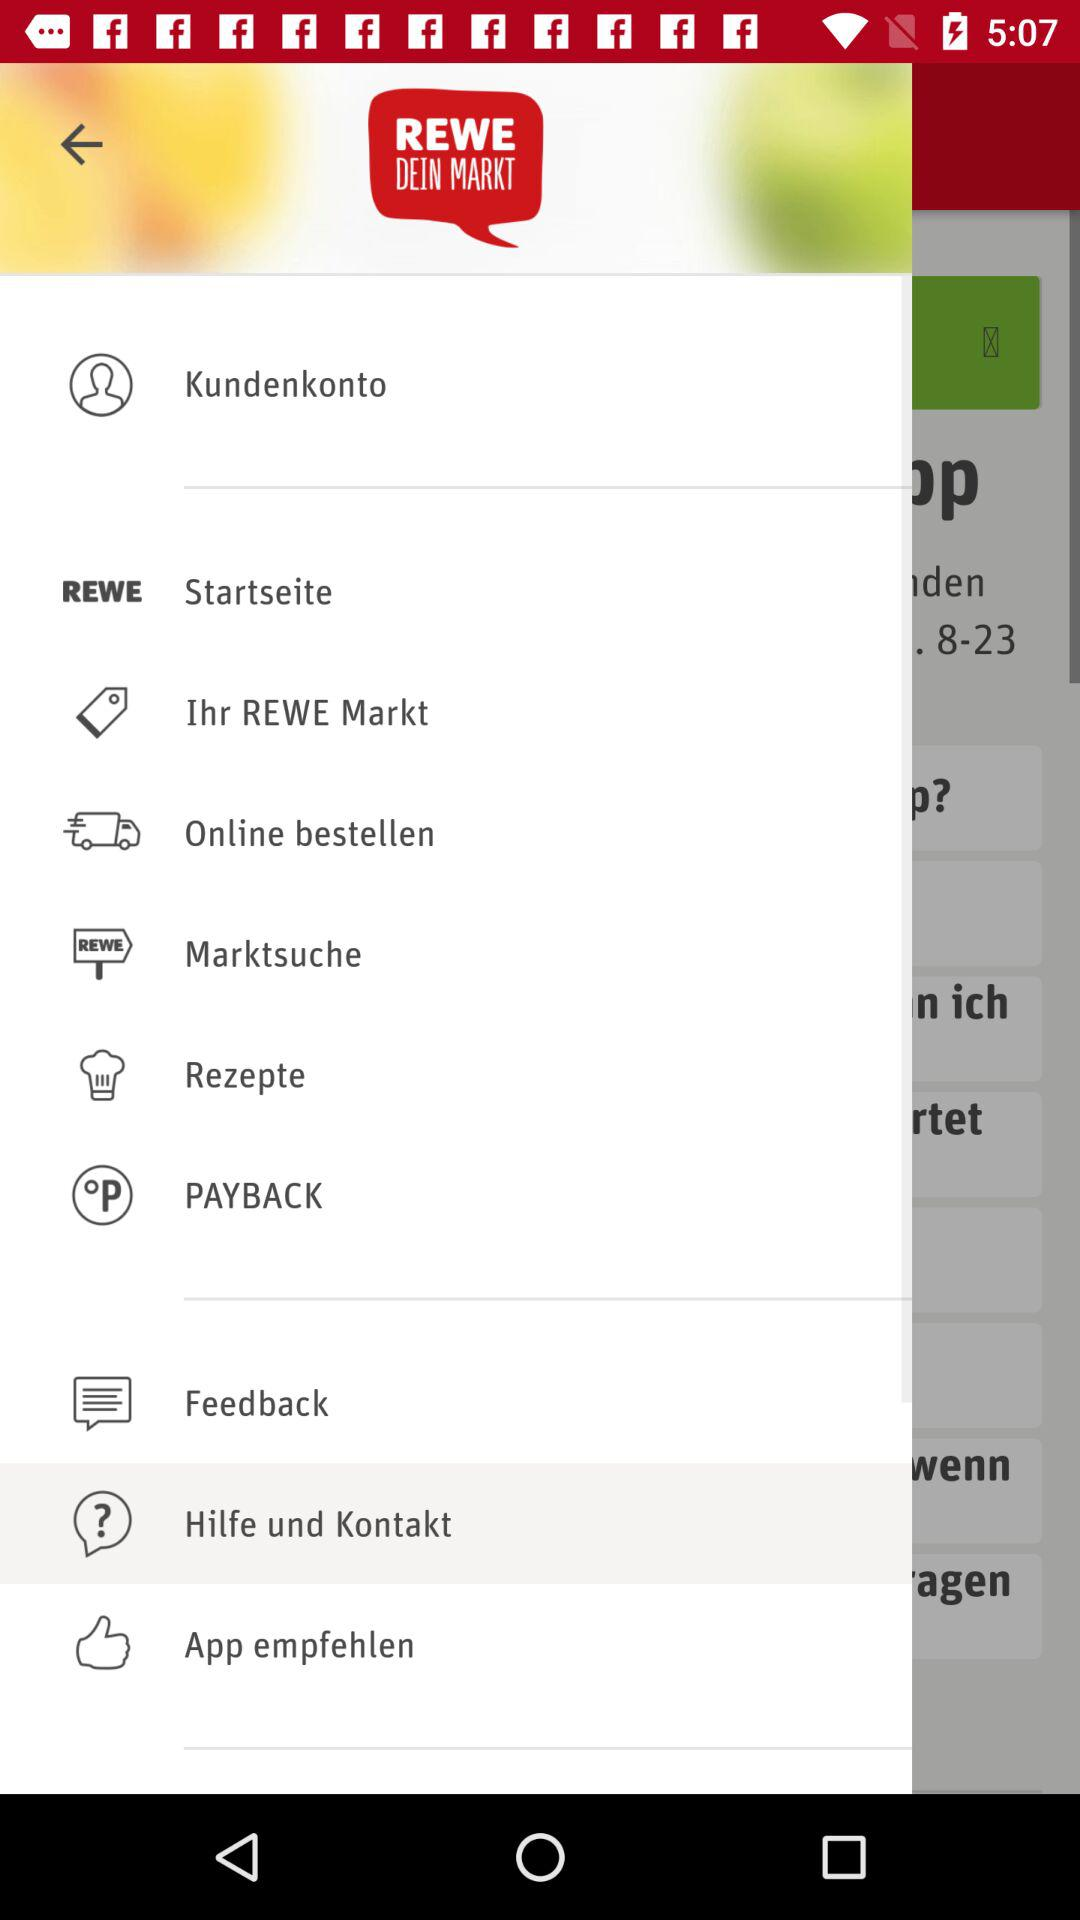What is the application name? The application name is "REWE DEIN MARKT". 